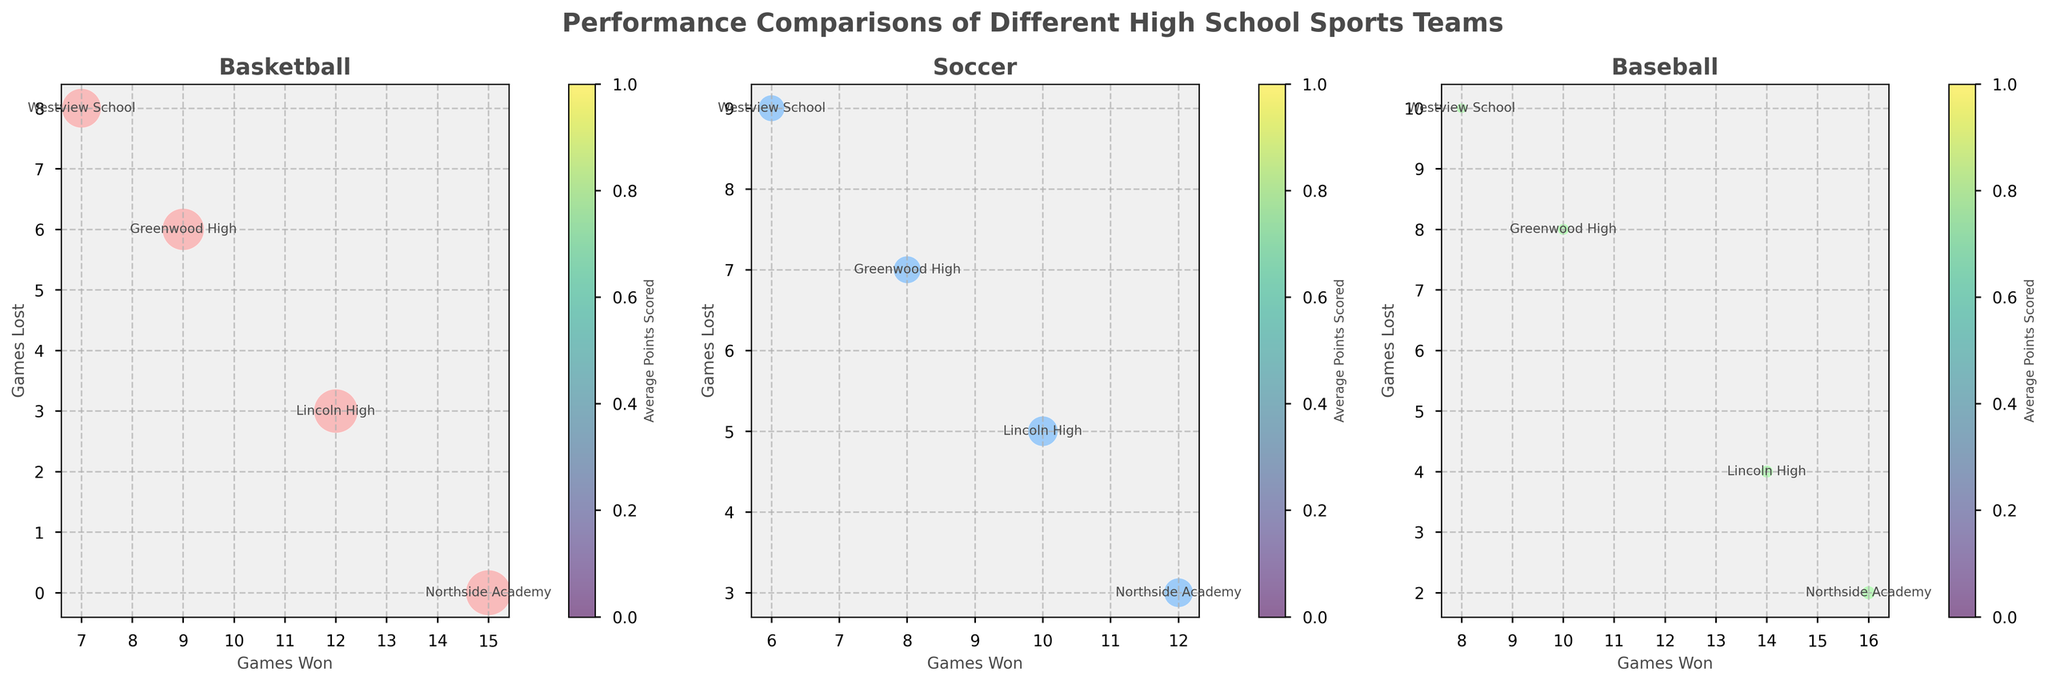What is the title of the figure? The title is usually located at the top of the figure and summarizes the content presented.
Answer: Performance Comparisons of Different High School Sports Teams How many teams participated in the basketball season? Look at the basketball subplot and count the number of data points (bubbles) representing different teams.
Answer: Four Which sport subplot shows the least number of games lost by its teams? Compare the "Games Lost" axis across all three subplots and identify the one with the least values.
Answer: Baseball Which team scored the highest average points in the late Fall 2022 Basketball season? Look at the bubble sizes in the Basketball subplot, as they represent average points scored. Identify the largest bubble and the corresponding team.
Answer: Northside Academy How many total games have Lincoln High’s teams won across all seasons? Sum up the "Games Won" of Lincoln High in each sport from the subplots. Lincoln High's won games are: Basketball (12), Soccer (10), Baseball (14) which gives 12+10+14 = 36 games in total.
Answer: 36 Which team has the lowest average points scored in the Early Summer 2023 Baseball season? Look at the bubble sizes in the Baseball subplot, as smaller bubbles represent lower average points scored. Identify the smallest bubble and the corresponding team.
Answer: Westview School How does Greenwood High's performance in Soccer compare to its performance in Baseball? Compare the bubbles for Greenwood High in the Soccer and Baseball subplots on both axes (Games Won and Games Lost) and bubble size (Average Points Scored). In Soccer: 8 won, 7 lost, 29 points scored. In Baseball: 10 won, 8 lost, 5 points scored. Greenwood performs better in terms of wins and slightly worse in losses in Baseball, but significantly worse in average points scored.
Answer: Fewer wins, more losses in Soccer with higher points Which team in the Spring 2023 Soccer season has the least amount of games lost? Look at the Soccer subplot and identify the team with the smallest value on the "Games Lost" axis.
Answer: Northside Academy Is there any sport where Westview School did better than other teams in terms of games won? Look at the number of "Games Won" for Westview School across all three subplots and compare them to other teams in each sport. Westview School does not have the highest number of games won in any of the sports.
Answer: No Who is the standout player for Lincoln High's soccer team in Spring 2023? Refer to the illustration annotations or legend, which in this case, would point to the standout player based on additional information provided.
Answer: Ethan Davis 